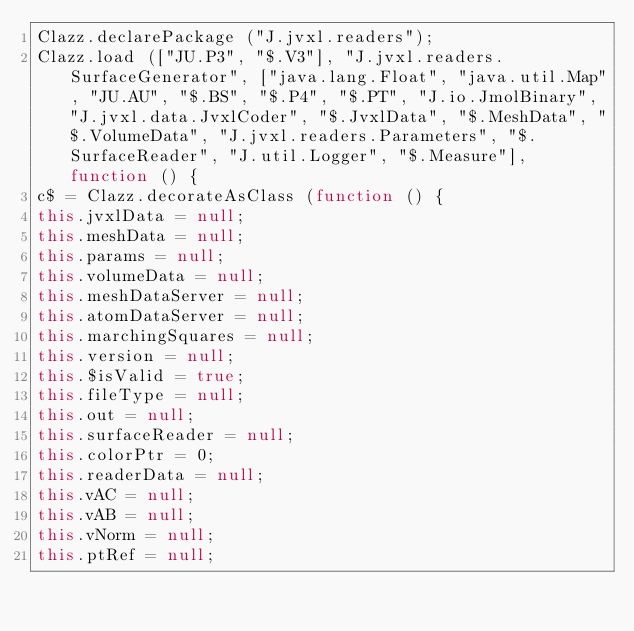<code> <loc_0><loc_0><loc_500><loc_500><_JavaScript_>Clazz.declarePackage ("J.jvxl.readers");
Clazz.load (["JU.P3", "$.V3"], "J.jvxl.readers.SurfaceGenerator", ["java.lang.Float", "java.util.Map", "JU.AU", "$.BS", "$.P4", "$.PT", "J.io.JmolBinary", "J.jvxl.data.JvxlCoder", "$.JvxlData", "$.MeshData", "$.VolumeData", "J.jvxl.readers.Parameters", "$.SurfaceReader", "J.util.Logger", "$.Measure"], function () {
c$ = Clazz.decorateAsClass (function () {
this.jvxlData = null;
this.meshData = null;
this.params = null;
this.volumeData = null;
this.meshDataServer = null;
this.atomDataServer = null;
this.marchingSquares = null;
this.version = null;
this.$isValid = true;
this.fileType = null;
this.out = null;
this.surfaceReader = null;
this.colorPtr = 0;
this.readerData = null;
this.vAC = null;
this.vAB = null;
this.vNorm = null;
this.ptRef = null;</code> 